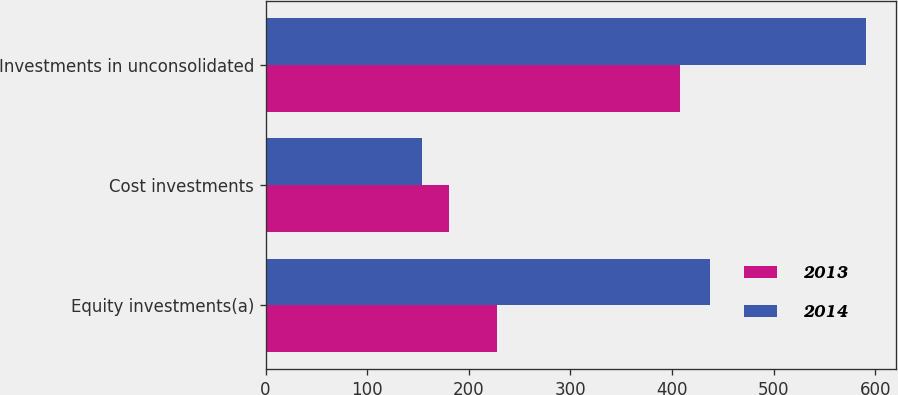Convert chart. <chart><loc_0><loc_0><loc_500><loc_500><stacked_bar_chart><ecel><fcel>Equity investments(a)<fcel>Cost investments<fcel>Investments in unconsolidated<nl><fcel>2013<fcel>228<fcel>180<fcel>408<nl><fcel>2014<fcel>437<fcel>154<fcel>591<nl></chart> 